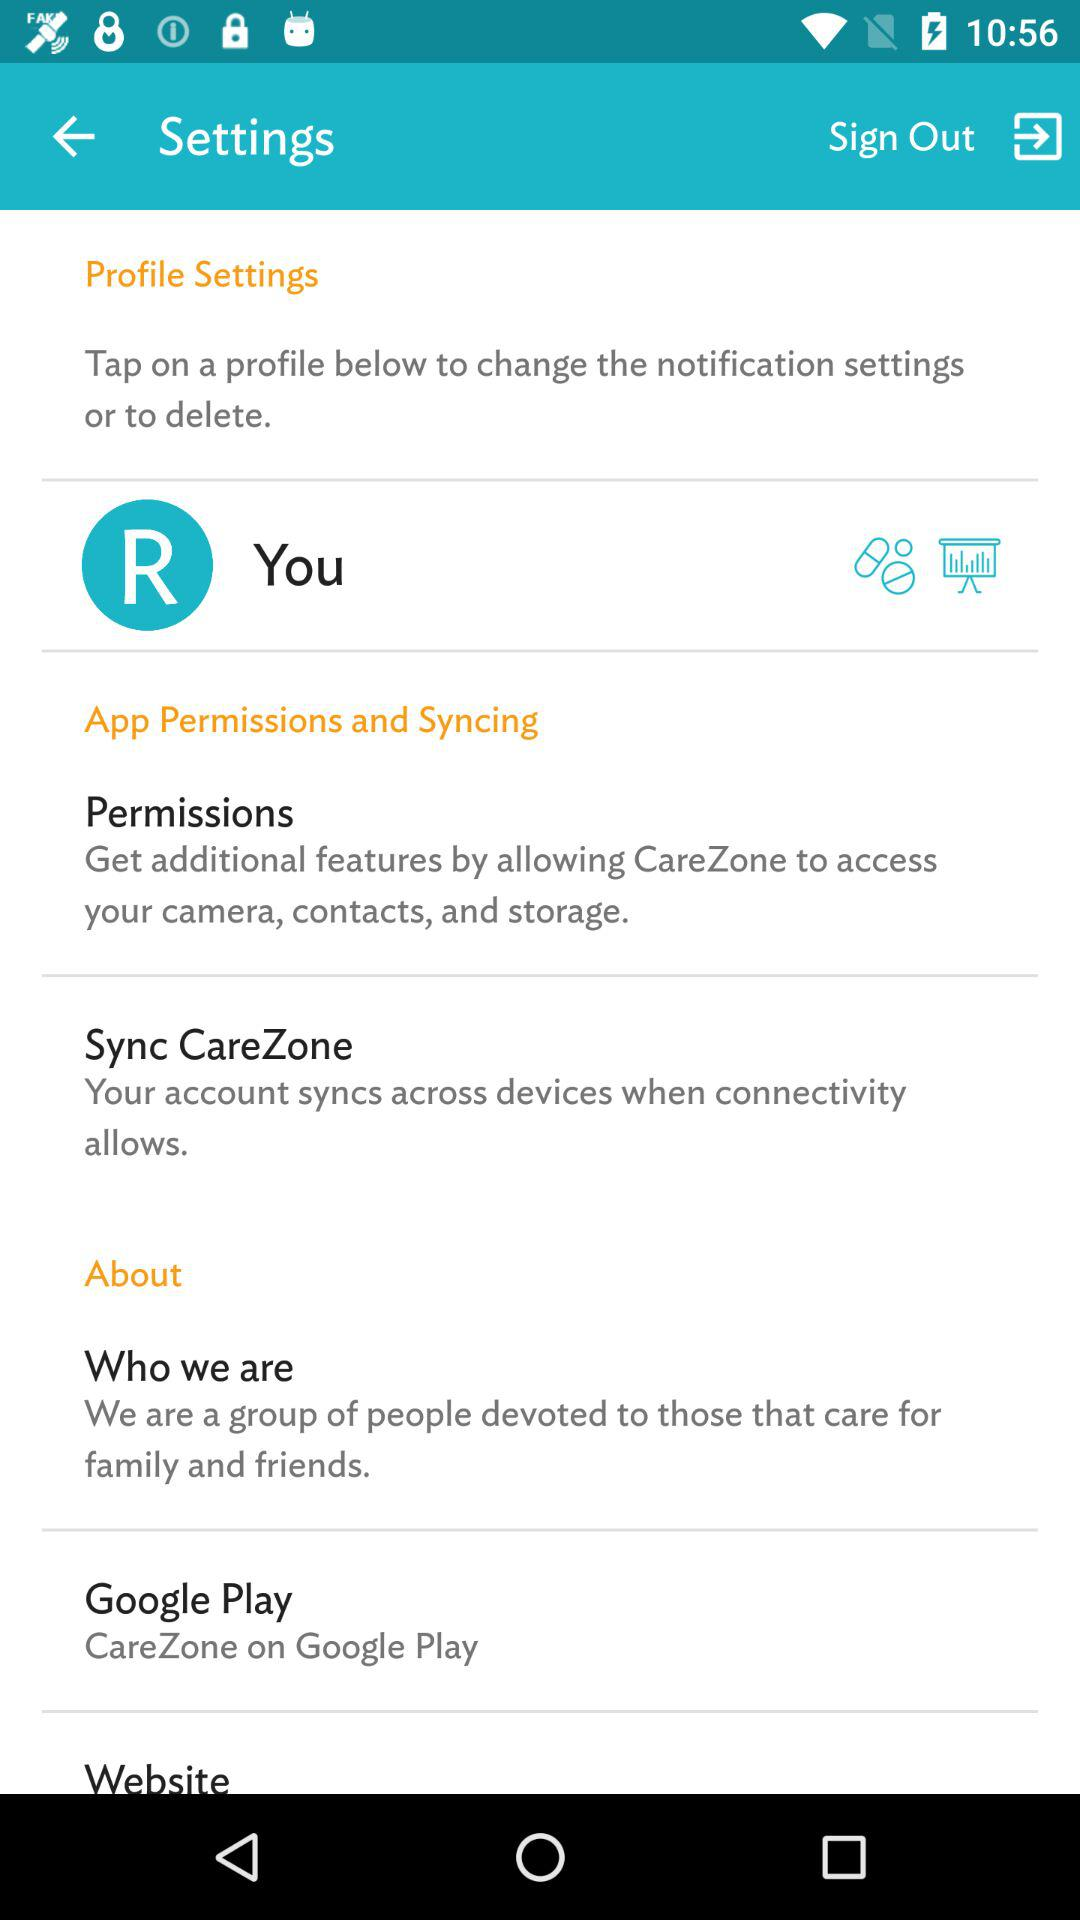Where is the application available? The application is available on "Google Play". 